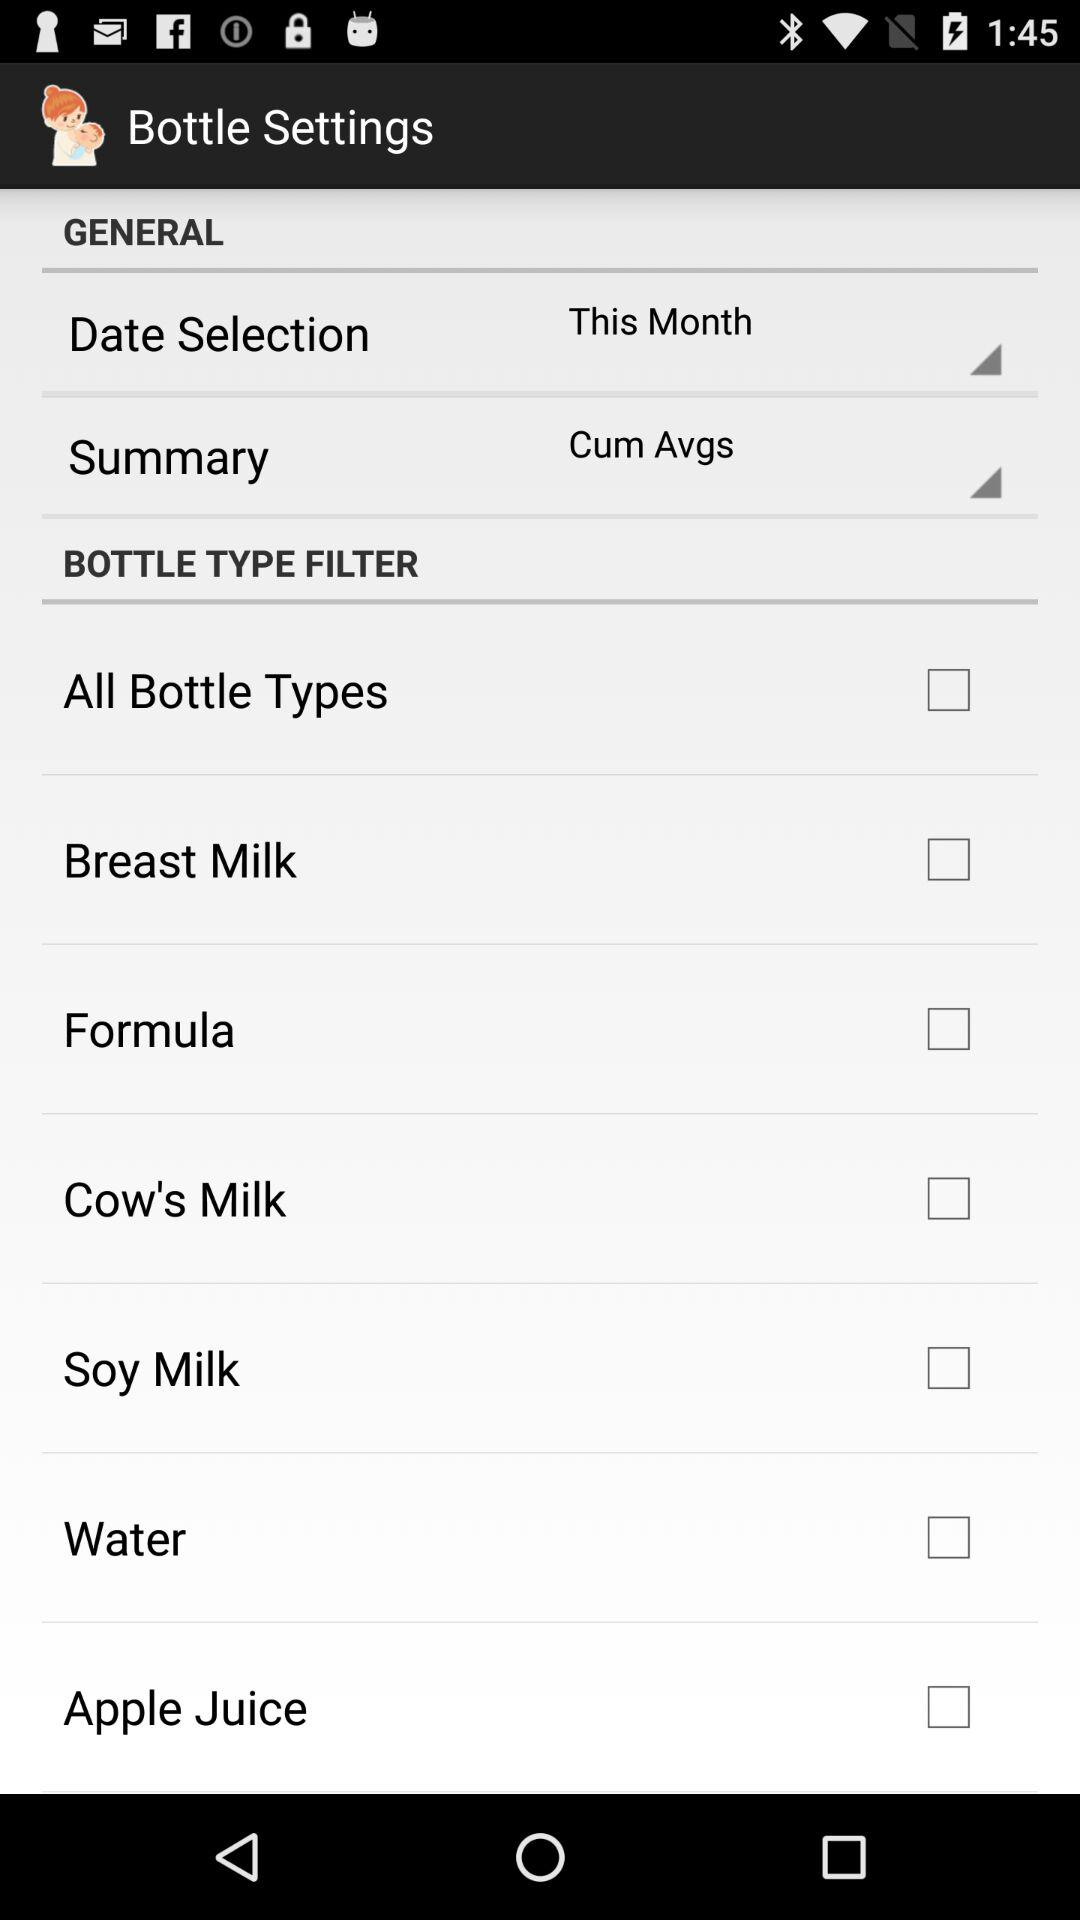When was "Bottle Settings" last updated?
When the provided information is insufficient, respond with <no answer>. <no answer> 